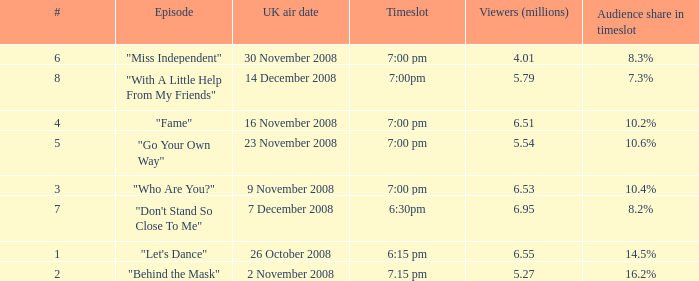Name the uk air date for audience share in timeslot in 7.3% 14 December 2008. 